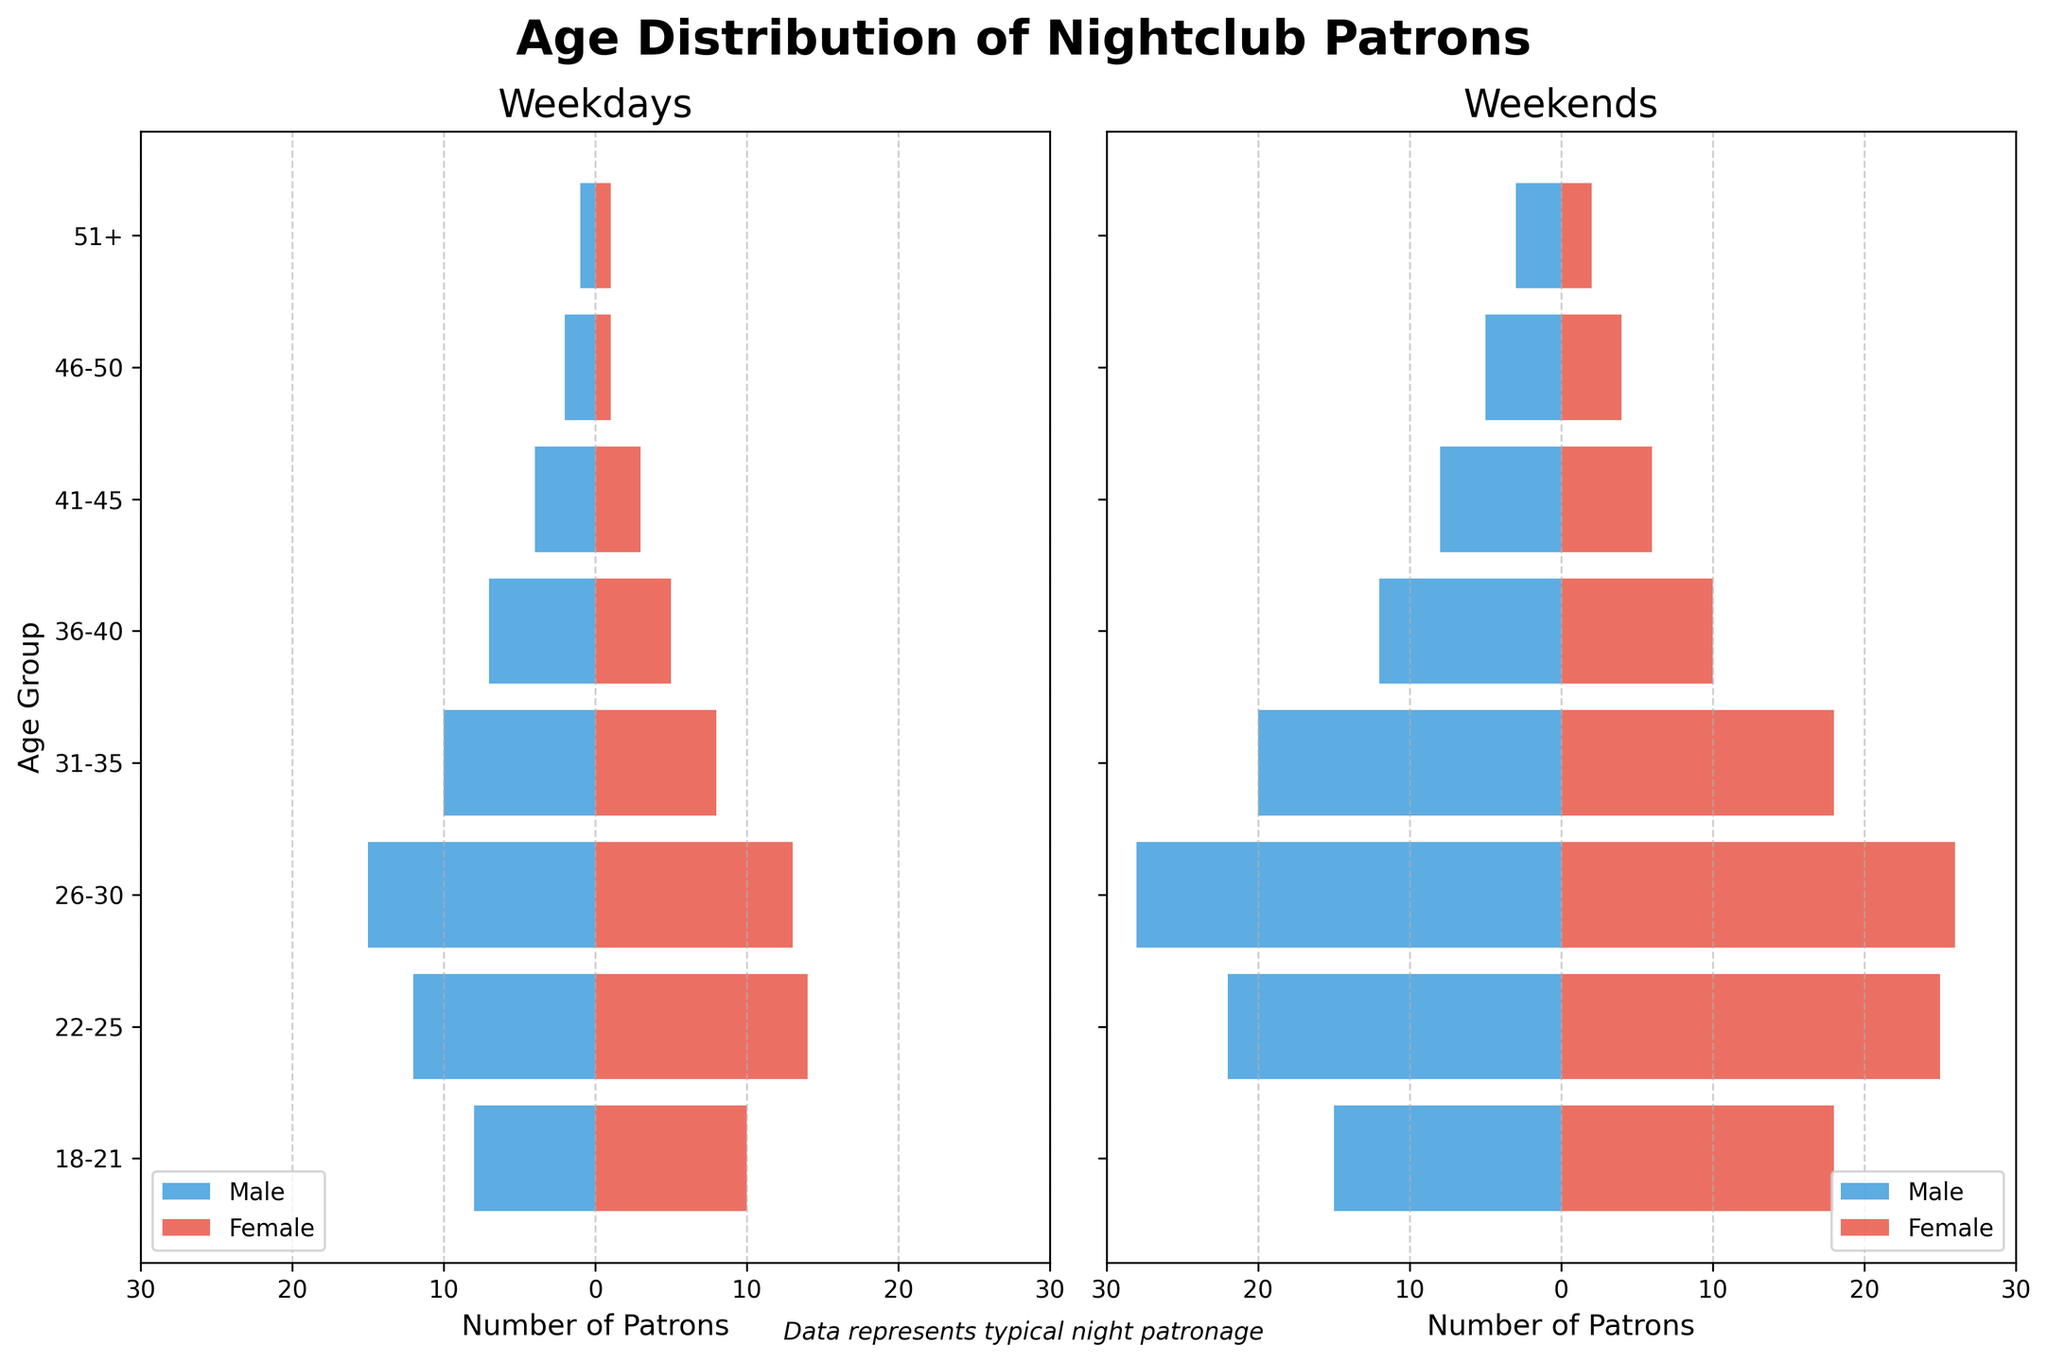What is the title of the figure? The title is displayed at the top of the figure, and it reads "Age Distribution of Nightclub Patrons."
Answer: Age Distribution of Nightclub Patrons What is the age group with the highest number of female patrons on weekdays? By looking at the weekday columns for females, the 22-25 age group has the highest bar reaching 14 patrons.
Answer: 22-25 Which gender has more patrons aged 26-30 on weekends? On the weekends side, the female bar for 26-30 is 26, while the male bar is 28. Thus, males have more patrons.
Answer: Males What is the total number of male patrons on a typical weekday? Sum the negative values as they represent male patrons: 8 + 12 + 15 + 10 + 7 + 4 + 2 + 1. The total is 59.
Answer: 59 How does the number of patrons aged 31-35 compare between weekdays and weekends? On weekdays, there are 10 males and 8 females (18 total). On weekends, there are 20 males and 18 females (38 total). So, the number is significantly higher on weekends.
Answer: Higher on weekends What age group sees the largest increase in female patrons from weekdays to weekends? By comparing the female patron bars for each age group, the 18-21 group jumps from 10 to 18, making this the largest increase (8 patrons).
Answer: 18-21 What's the difference in the number of female patrons aged 22-25 between weekdays and weekends? Weekend female patrons (25) minus weekday female patrons (14) equals 11.
Answer: 11 What is the pattern of change in patronage as age increases from 18 to 51+ during weekends? On weekends, both males and females show a decreasing trend in numbers as age increases, with peaks at younger ages.
Answer: Decreasing trend How many more male patrons aged 46-50 are there on weekends compared to weekdays? Weekend males (5) minus weekday males (2) equals 3 more male patrons.
Answer: 3 What is the sum of male and female patrons aged 18-21 on weekends? Combining male (15) and female (18) patrons gives a sum of 33.
Answer: 33 